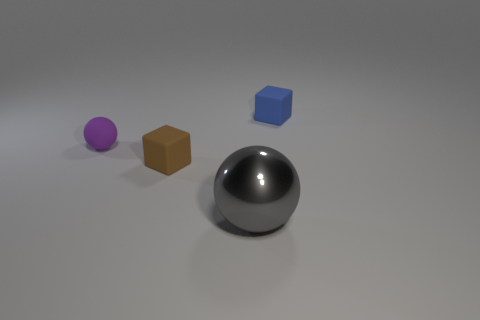There is a matte block behind the purple ball behind the brown matte thing; what color is it?
Your answer should be compact. Blue. Is there another large thing of the same color as the metal object?
Your answer should be compact. No. There is a blue object that is the same size as the brown thing; what shape is it?
Offer a very short reply. Cube. How many purple matte things are to the right of the cube that is in front of the small blue thing?
Make the answer very short. 0. Is the color of the small ball the same as the big thing?
Give a very brief answer. No. What number of other objects are the same material as the tiny brown thing?
Your response must be concise. 2. There is a small object left of the small rubber thing in front of the small purple ball; what is its shape?
Offer a terse response. Sphere. There is a rubber cube that is to the right of the big metallic sphere; how big is it?
Give a very brief answer. Small. Does the small brown cube have the same material as the purple sphere?
Make the answer very short. Yes. What shape is the small purple object that is made of the same material as the brown thing?
Ensure brevity in your answer.  Sphere. 